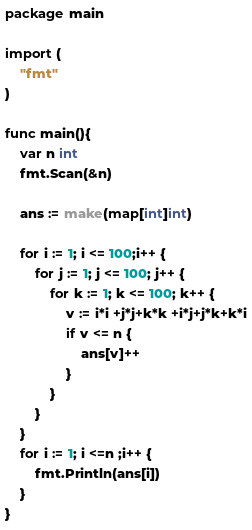<code> <loc_0><loc_0><loc_500><loc_500><_Go_>package main

import (
	"fmt"
)

func main(){
	var n int
	fmt.Scan(&n)

	ans := make(map[int]int)

	for i := 1; i <= 100;i++ {
		for j := 1; j <= 100; j++ {
			for k := 1; k <= 100; k++ {
				v := i*i +j*j+k*k +i*j+j*k+k*i
				if v <= n {
					ans[v]++
				}
			}
		}
	}
	for i := 1; i <=n ;i++ {
		fmt.Println(ans[i])
	}
}



</code> 